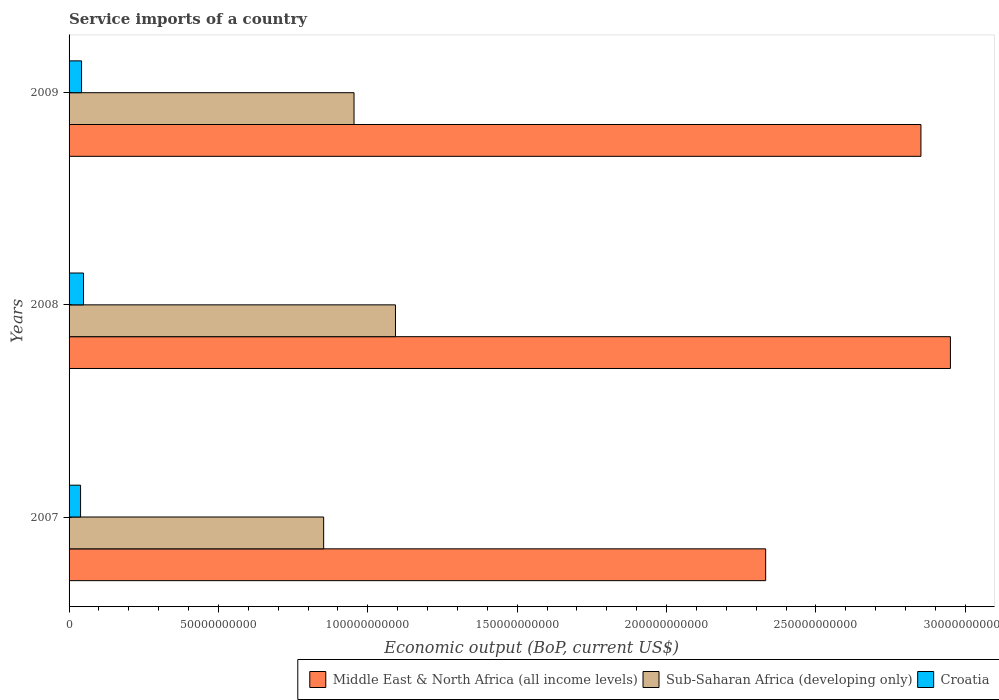How many different coloured bars are there?
Your answer should be very brief. 3. Are the number of bars per tick equal to the number of legend labels?
Offer a terse response. Yes. Are the number of bars on each tick of the Y-axis equal?
Your answer should be very brief. Yes. What is the label of the 1st group of bars from the top?
Offer a terse response. 2009. In how many cases, is the number of bars for a given year not equal to the number of legend labels?
Make the answer very short. 0. What is the service imports in Middle East & North Africa (all income levels) in 2008?
Give a very brief answer. 2.95e+11. Across all years, what is the maximum service imports in Middle East & North Africa (all income levels)?
Ensure brevity in your answer.  2.95e+11. Across all years, what is the minimum service imports in Sub-Saharan Africa (developing only)?
Ensure brevity in your answer.  8.52e+1. In which year was the service imports in Middle East & North Africa (all income levels) maximum?
Your response must be concise. 2008. In which year was the service imports in Sub-Saharan Africa (developing only) minimum?
Provide a short and direct response. 2007. What is the total service imports in Croatia in the graph?
Your answer should be very brief. 1.29e+1. What is the difference between the service imports in Sub-Saharan Africa (developing only) in 2008 and that in 2009?
Provide a succinct answer. 1.39e+1. What is the difference between the service imports in Croatia in 2009 and the service imports in Middle East & North Africa (all income levels) in 2008?
Ensure brevity in your answer.  -2.91e+11. What is the average service imports in Croatia per year?
Keep it short and to the point. 4.29e+09. In the year 2008, what is the difference between the service imports in Sub-Saharan Africa (developing only) and service imports in Croatia?
Your answer should be compact. 1.04e+11. What is the ratio of the service imports in Middle East & North Africa (all income levels) in 2007 to that in 2009?
Make the answer very short. 0.82. Is the service imports in Middle East & North Africa (all income levels) in 2007 less than that in 2008?
Keep it short and to the point. Yes. Is the difference between the service imports in Sub-Saharan Africa (developing only) in 2007 and 2008 greater than the difference between the service imports in Croatia in 2007 and 2008?
Your answer should be compact. No. What is the difference between the highest and the second highest service imports in Croatia?
Provide a short and direct response. 6.48e+08. What is the difference between the highest and the lowest service imports in Middle East & North Africa (all income levels)?
Ensure brevity in your answer.  6.18e+1. In how many years, is the service imports in Croatia greater than the average service imports in Croatia taken over all years?
Ensure brevity in your answer.  1. Is the sum of the service imports in Middle East & North Africa (all income levels) in 2008 and 2009 greater than the maximum service imports in Croatia across all years?
Your answer should be compact. Yes. What does the 2nd bar from the top in 2009 represents?
Offer a terse response. Sub-Saharan Africa (developing only). What does the 1st bar from the bottom in 2007 represents?
Your response must be concise. Middle East & North Africa (all income levels). How many bars are there?
Keep it short and to the point. 9. Are all the bars in the graph horizontal?
Ensure brevity in your answer.  Yes. Does the graph contain grids?
Offer a very short reply. No. How many legend labels are there?
Offer a very short reply. 3. How are the legend labels stacked?
Make the answer very short. Horizontal. What is the title of the graph?
Keep it short and to the point. Service imports of a country. Does "Sweden" appear as one of the legend labels in the graph?
Your answer should be compact. No. What is the label or title of the X-axis?
Make the answer very short. Economic output (BoP, current US$). What is the label or title of the Y-axis?
Offer a very short reply. Years. What is the Economic output (BoP, current US$) of Middle East & North Africa (all income levels) in 2007?
Give a very brief answer. 2.33e+11. What is the Economic output (BoP, current US$) of Sub-Saharan Africa (developing only) in 2007?
Your answer should be very brief. 8.52e+1. What is the Economic output (BoP, current US$) of Croatia in 2007?
Your answer should be very brief. 3.84e+09. What is the Economic output (BoP, current US$) of Middle East & North Africa (all income levels) in 2008?
Offer a very short reply. 2.95e+11. What is the Economic output (BoP, current US$) in Sub-Saharan Africa (developing only) in 2008?
Your answer should be very brief. 1.09e+11. What is the Economic output (BoP, current US$) in Croatia in 2008?
Offer a terse response. 4.83e+09. What is the Economic output (BoP, current US$) of Middle East & North Africa (all income levels) in 2009?
Keep it short and to the point. 2.85e+11. What is the Economic output (BoP, current US$) of Sub-Saharan Africa (developing only) in 2009?
Provide a succinct answer. 9.54e+1. What is the Economic output (BoP, current US$) in Croatia in 2009?
Offer a very short reply. 4.18e+09. Across all years, what is the maximum Economic output (BoP, current US$) of Middle East & North Africa (all income levels)?
Keep it short and to the point. 2.95e+11. Across all years, what is the maximum Economic output (BoP, current US$) in Sub-Saharan Africa (developing only)?
Provide a short and direct response. 1.09e+11. Across all years, what is the maximum Economic output (BoP, current US$) in Croatia?
Your response must be concise. 4.83e+09. Across all years, what is the minimum Economic output (BoP, current US$) in Middle East & North Africa (all income levels)?
Keep it short and to the point. 2.33e+11. Across all years, what is the minimum Economic output (BoP, current US$) of Sub-Saharan Africa (developing only)?
Offer a very short reply. 8.52e+1. Across all years, what is the minimum Economic output (BoP, current US$) of Croatia?
Your answer should be very brief. 3.84e+09. What is the total Economic output (BoP, current US$) of Middle East & North Africa (all income levels) in the graph?
Offer a terse response. 8.13e+11. What is the total Economic output (BoP, current US$) of Sub-Saharan Africa (developing only) in the graph?
Give a very brief answer. 2.90e+11. What is the total Economic output (BoP, current US$) in Croatia in the graph?
Provide a short and direct response. 1.29e+1. What is the difference between the Economic output (BoP, current US$) in Middle East & North Africa (all income levels) in 2007 and that in 2008?
Your answer should be very brief. -6.18e+1. What is the difference between the Economic output (BoP, current US$) of Sub-Saharan Africa (developing only) in 2007 and that in 2008?
Provide a succinct answer. -2.40e+1. What is the difference between the Economic output (BoP, current US$) in Croatia in 2007 and that in 2008?
Your answer should be compact. -9.87e+08. What is the difference between the Economic output (BoP, current US$) in Middle East & North Africa (all income levels) in 2007 and that in 2009?
Keep it short and to the point. -5.20e+1. What is the difference between the Economic output (BoP, current US$) in Sub-Saharan Africa (developing only) in 2007 and that in 2009?
Give a very brief answer. -1.02e+1. What is the difference between the Economic output (BoP, current US$) of Croatia in 2007 and that in 2009?
Your answer should be compact. -3.39e+08. What is the difference between the Economic output (BoP, current US$) of Middle East & North Africa (all income levels) in 2008 and that in 2009?
Make the answer very short. 9.87e+09. What is the difference between the Economic output (BoP, current US$) of Sub-Saharan Africa (developing only) in 2008 and that in 2009?
Provide a short and direct response. 1.39e+1. What is the difference between the Economic output (BoP, current US$) of Croatia in 2008 and that in 2009?
Keep it short and to the point. 6.48e+08. What is the difference between the Economic output (BoP, current US$) in Middle East & North Africa (all income levels) in 2007 and the Economic output (BoP, current US$) in Sub-Saharan Africa (developing only) in 2008?
Make the answer very short. 1.24e+11. What is the difference between the Economic output (BoP, current US$) of Middle East & North Africa (all income levels) in 2007 and the Economic output (BoP, current US$) of Croatia in 2008?
Provide a short and direct response. 2.28e+11. What is the difference between the Economic output (BoP, current US$) in Sub-Saharan Africa (developing only) in 2007 and the Economic output (BoP, current US$) in Croatia in 2008?
Keep it short and to the point. 8.04e+1. What is the difference between the Economic output (BoP, current US$) in Middle East & North Africa (all income levels) in 2007 and the Economic output (BoP, current US$) in Sub-Saharan Africa (developing only) in 2009?
Keep it short and to the point. 1.38e+11. What is the difference between the Economic output (BoP, current US$) in Middle East & North Africa (all income levels) in 2007 and the Economic output (BoP, current US$) in Croatia in 2009?
Your response must be concise. 2.29e+11. What is the difference between the Economic output (BoP, current US$) of Sub-Saharan Africa (developing only) in 2007 and the Economic output (BoP, current US$) of Croatia in 2009?
Make the answer very short. 8.10e+1. What is the difference between the Economic output (BoP, current US$) in Middle East & North Africa (all income levels) in 2008 and the Economic output (BoP, current US$) in Sub-Saharan Africa (developing only) in 2009?
Give a very brief answer. 2.00e+11. What is the difference between the Economic output (BoP, current US$) of Middle East & North Africa (all income levels) in 2008 and the Economic output (BoP, current US$) of Croatia in 2009?
Ensure brevity in your answer.  2.91e+11. What is the difference between the Economic output (BoP, current US$) of Sub-Saharan Africa (developing only) in 2008 and the Economic output (BoP, current US$) of Croatia in 2009?
Offer a terse response. 1.05e+11. What is the average Economic output (BoP, current US$) in Middle East & North Africa (all income levels) per year?
Your answer should be compact. 2.71e+11. What is the average Economic output (BoP, current US$) of Sub-Saharan Africa (developing only) per year?
Make the answer very short. 9.66e+1. What is the average Economic output (BoP, current US$) in Croatia per year?
Your response must be concise. 4.29e+09. In the year 2007, what is the difference between the Economic output (BoP, current US$) of Middle East & North Africa (all income levels) and Economic output (BoP, current US$) of Sub-Saharan Africa (developing only)?
Keep it short and to the point. 1.48e+11. In the year 2007, what is the difference between the Economic output (BoP, current US$) in Middle East & North Africa (all income levels) and Economic output (BoP, current US$) in Croatia?
Keep it short and to the point. 2.29e+11. In the year 2007, what is the difference between the Economic output (BoP, current US$) of Sub-Saharan Africa (developing only) and Economic output (BoP, current US$) of Croatia?
Your answer should be compact. 8.14e+1. In the year 2008, what is the difference between the Economic output (BoP, current US$) of Middle East & North Africa (all income levels) and Economic output (BoP, current US$) of Sub-Saharan Africa (developing only)?
Give a very brief answer. 1.86e+11. In the year 2008, what is the difference between the Economic output (BoP, current US$) of Middle East & North Africa (all income levels) and Economic output (BoP, current US$) of Croatia?
Ensure brevity in your answer.  2.90e+11. In the year 2008, what is the difference between the Economic output (BoP, current US$) of Sub-Saharan Africa (developing only) and Economic output (BoP, current US$) of Croatia?
Provide a succinct answer. 1.04e+11. In the year 2009, what is the difference between the Economic output (BoP, current US$) of Middle East & North Africa (all income levels) and Economic output (BoP, current US$) of Sub-Saharan Africa (developing only)?
Your answer should be very brief. 1.90e+11. In the year 2009, what is the difference between the Economic output (BoP, current US$) in Middle East & North Africa (all income levels) and Economic output (BoP, current US$) in Croatia?
Offer a very short reply. 2.81e+11. In the year 2009, what is the difference between the Economic output (BoP, current US$) of Sub-Saharan Africa (developing only) and Economic output (BoP, current US$) of Croatia?
Your answer should be compact. 9.12e+1. What is the ratio of the Economic output (BoP, current US$) in Middle East & North Africa (all income levels) in 2007 to that in 2008?
Keep it short and to the point. 0.79. What is the ratio of the Economic output (BoP, current US$) in Sub-Saharan Africa (developing only) in 2007 to that in 2008?
Your answer should be very brief. 0.78. What is the ratio of the Economic output (BoP, current US$) of Croatia in 2007 to that in 2008?
Your answer should be very brief. 0.8. What is the ratio of the Economic output (BoP, current US$) of Middle East & North Africa (all income levels) in 2007 to that in 2009?
Ensure brevity in your answer.  0.82. What is the ratio of the Economic output (BoP, current US$) in Sub-Saharan Africa (developing only) in 2007 to that in 2009?
Offer a very short reply. 0.89. What is the ratio of the Economic output (BoP, current US$) of Croatia in 2007 to that in 2009?
Your answer should be very brief. 0.92. What is the ratio of the Economic output (BoP, current US$) of Middle East & North Africa (all income levels) in 2008 to that in 2009?
Your answer should be very brief. 1.03. What is the ratio of the Economic output (BoP, current US$) of Sub-Saharan Africa (developing only) in 2008 to that in 2009?
Provide a short and direct response. 1.15. What is the ratio of the Economic output (BoP, current US$) in Croatia in 2008 to that in 2009?
Your answer should be compact. 1.15. What is the difference between the highest and the second highest Economic output (BoP, current US$) in Middle East & North Africa (all income levels)?
Provide a succinct answer. 9.87e+09. What is the difference between the highest and the second highest Economic output (BoP, current US$) in Sub-Saharan Africa (developing only)?
Your answer should be very brief. 1.39e+1. What is the difference between the highest and the second highest Economic output (BoP, current US$) of Croatia?
Your answer should be very brief. 6.48e+08. What is the difference between the highest and the lowest Economic output (BoP, current US$) of Middle East & North Africa (all income levels)?
Provide a succinct answer. 6.18e+1. What is the difference between the highest and the lowest Economic output (BoP, current US$) of Sub-Saharan Africa (developing only)?
Provide a succinct answer. 2.40e+1. What is the difference between the highest and the lowest Economic output (BoP, current US$) in Croatia?
Provide a short and direct response. 9.87e+08. 